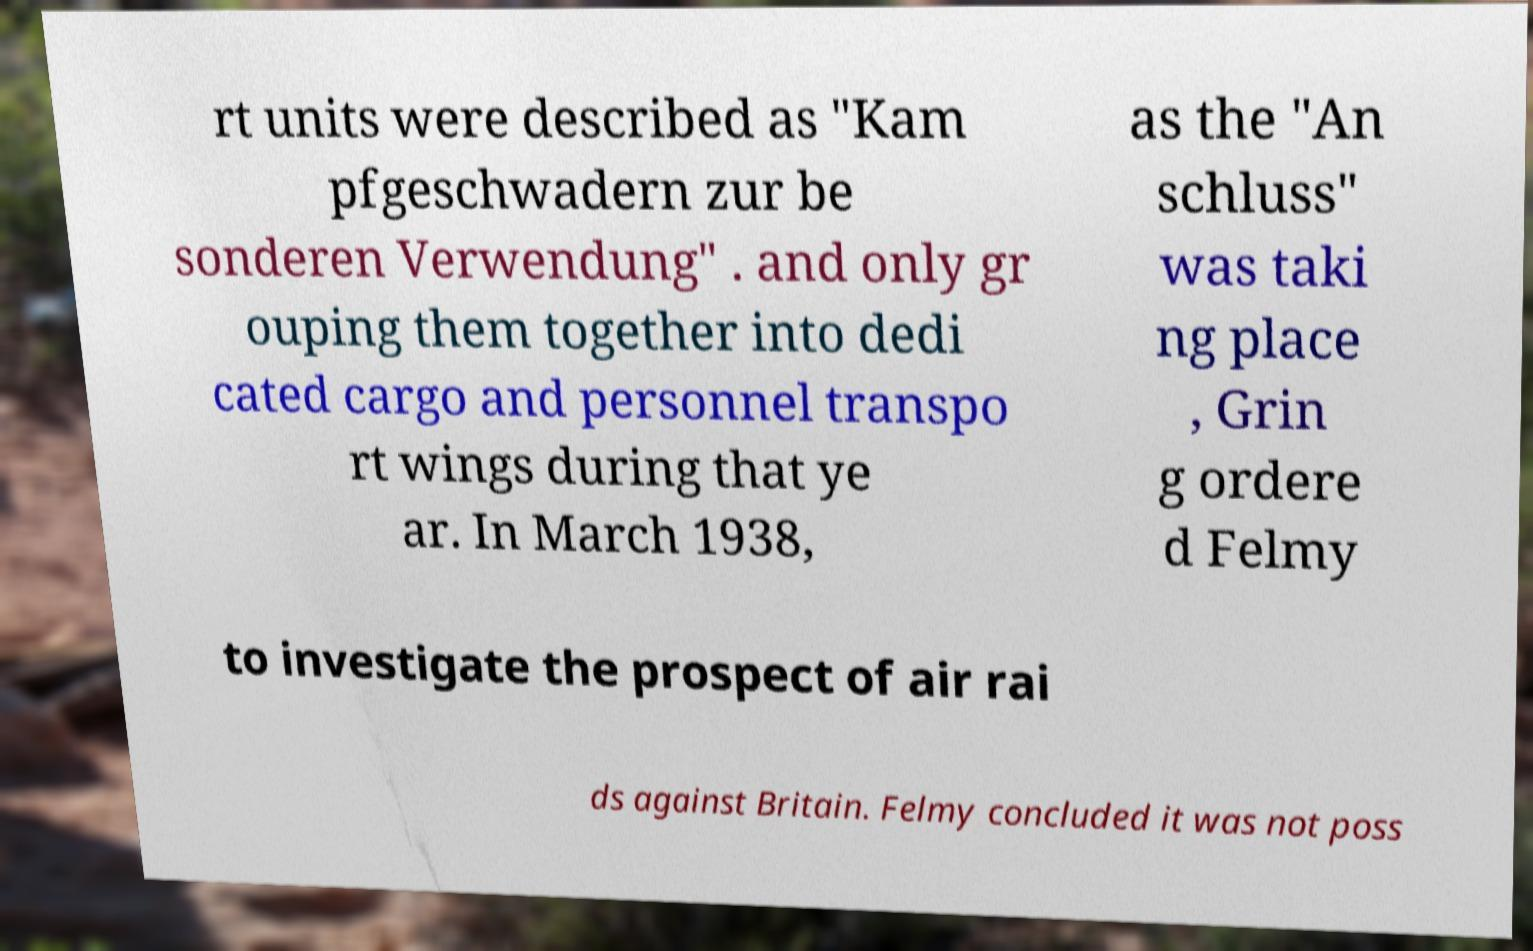Could you extract and type out the text from this image? rt units were described as "Kam pfgeschwadern zur be sonderen Verwendung" . and only gr ouping them together into dedi cated cargo and personnel transpo rt wings during that ye ar. In March 1938, as the "An schluss" was taki ng place , Grin g ordere d Felmy to investigate the prospect of air rai ds against Britain. Felmy concluded it was not poss 